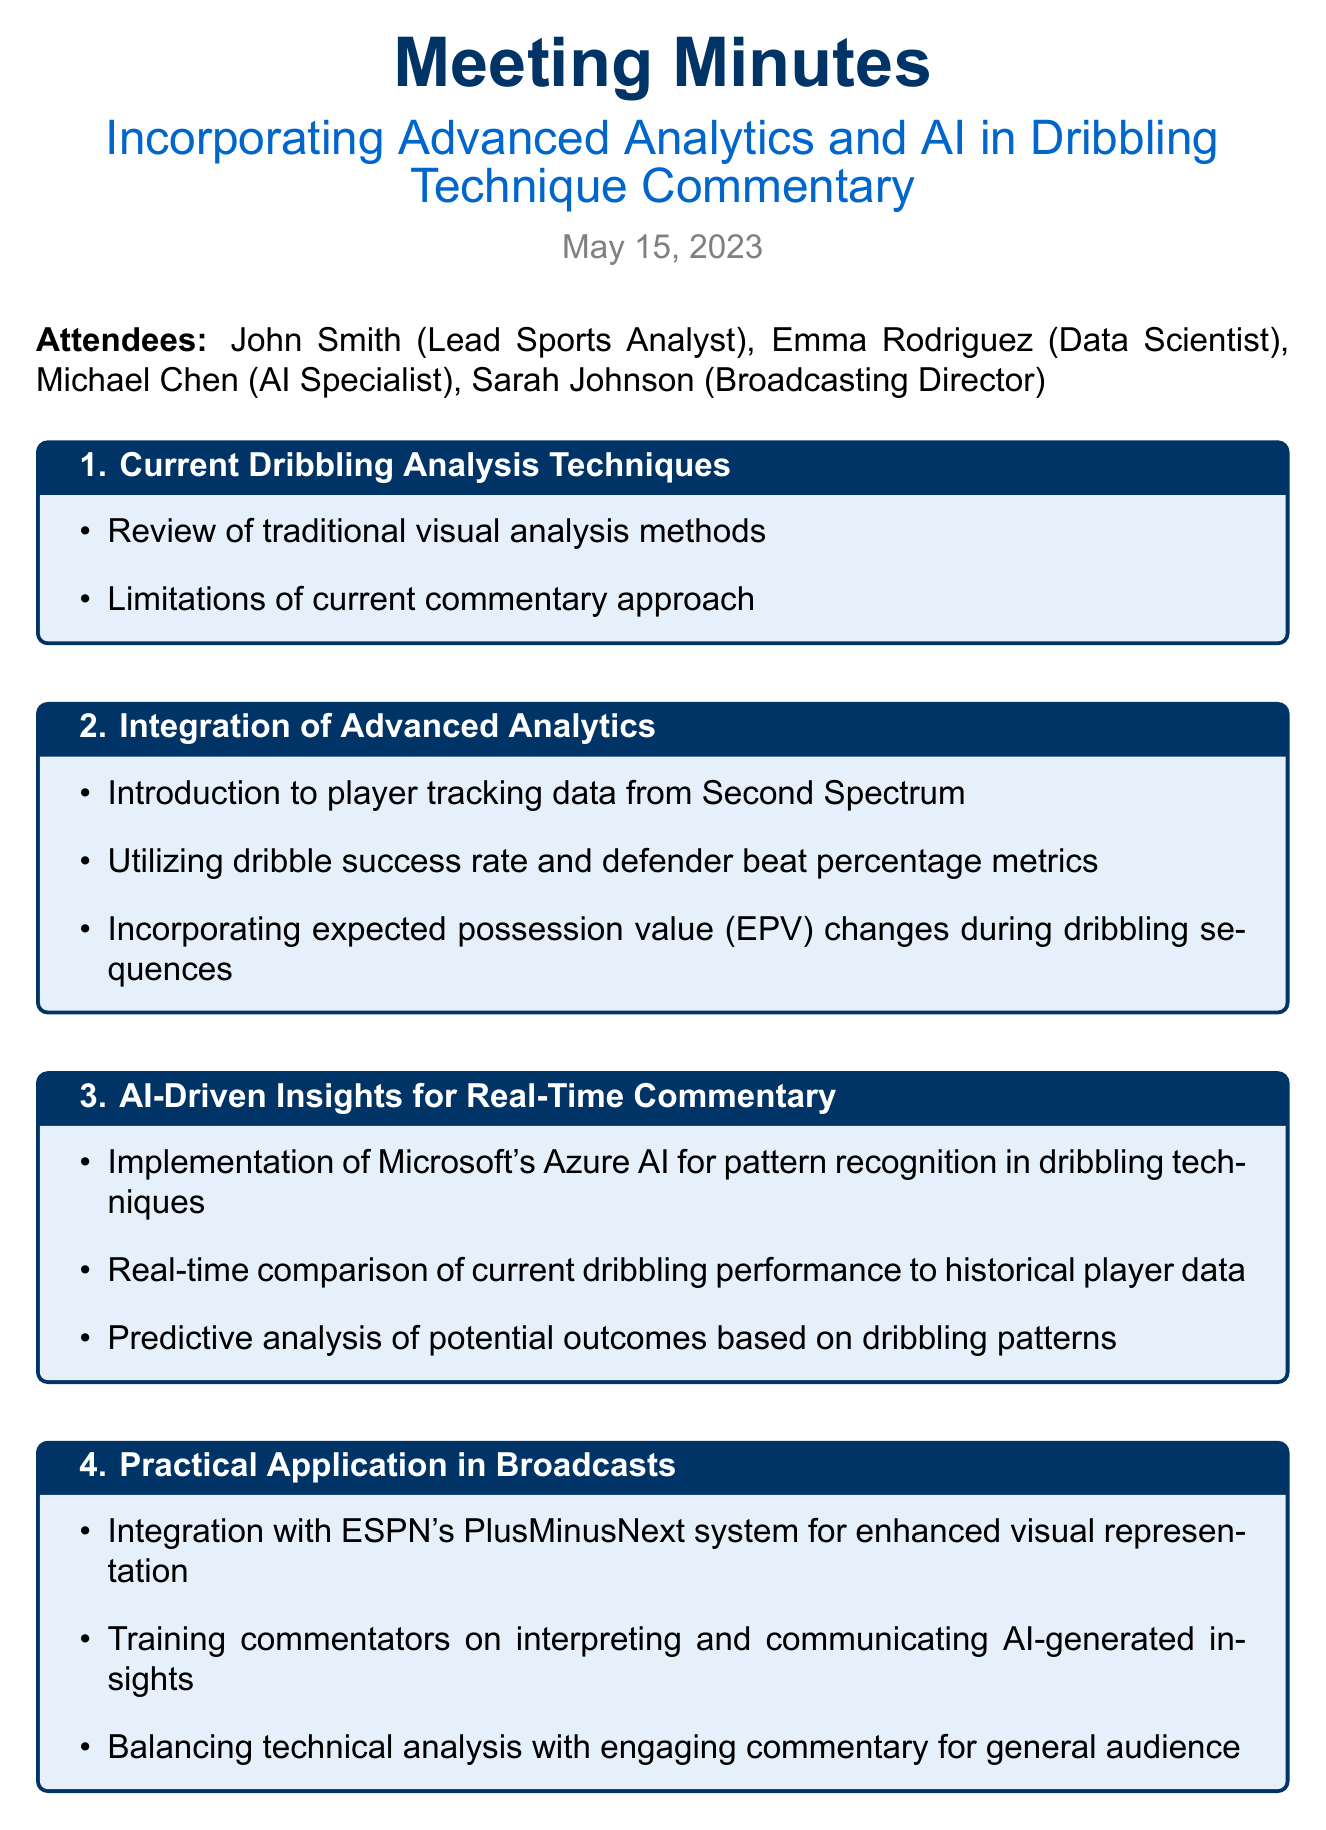What is the date of the meeting? The date of the meeting is stated at the beginning of the document.
Answer: May 15, 2023 Who is the Lead Sports Analyst? The document lists John Smith as the Lead Sports Analyst among the attendees.
Answer: John Smith What system will be integrated with ESPN's PlusMinusNext? This is mentioned in the Practical Application section as part of enhancing visual representation in broadcasts.
Answer: ESPN's PlusMinusNext What is a key metric utilized in the advanced analytics integration? The Integration of Advanced Analytics section refers to specific metrics to be used.
Answer: Dribble success rate What is one challenge related to AI processing mentioned? The Challenges and Considerations section highlights specific challenges associated with AI in commentary.
Answer: Minimal delay What is the first step in the Next Steps section? The steps outlined provide a clear approach starting from the pilot program.
Answer: Pilot program during NBA Summer League games What technology is being implemented for pattern recognition? The document specifies Microsoft's Azure AI for this purpose in the AI-Driven Insights section.
Answer: Microsoft's Azure AI How will commentators be trained according to the Practical Application section? The document details how commentators will learn to interpret insights generated by AI.
Answer: Training commentators on interpreting and communicating AI-generated insights 